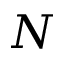<formula> <loc_0><loc_0><loc_500><loc_500>N</formula> 